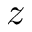<formula> <loc_0><loc_0><loc_500><loc_500>z</formula> 